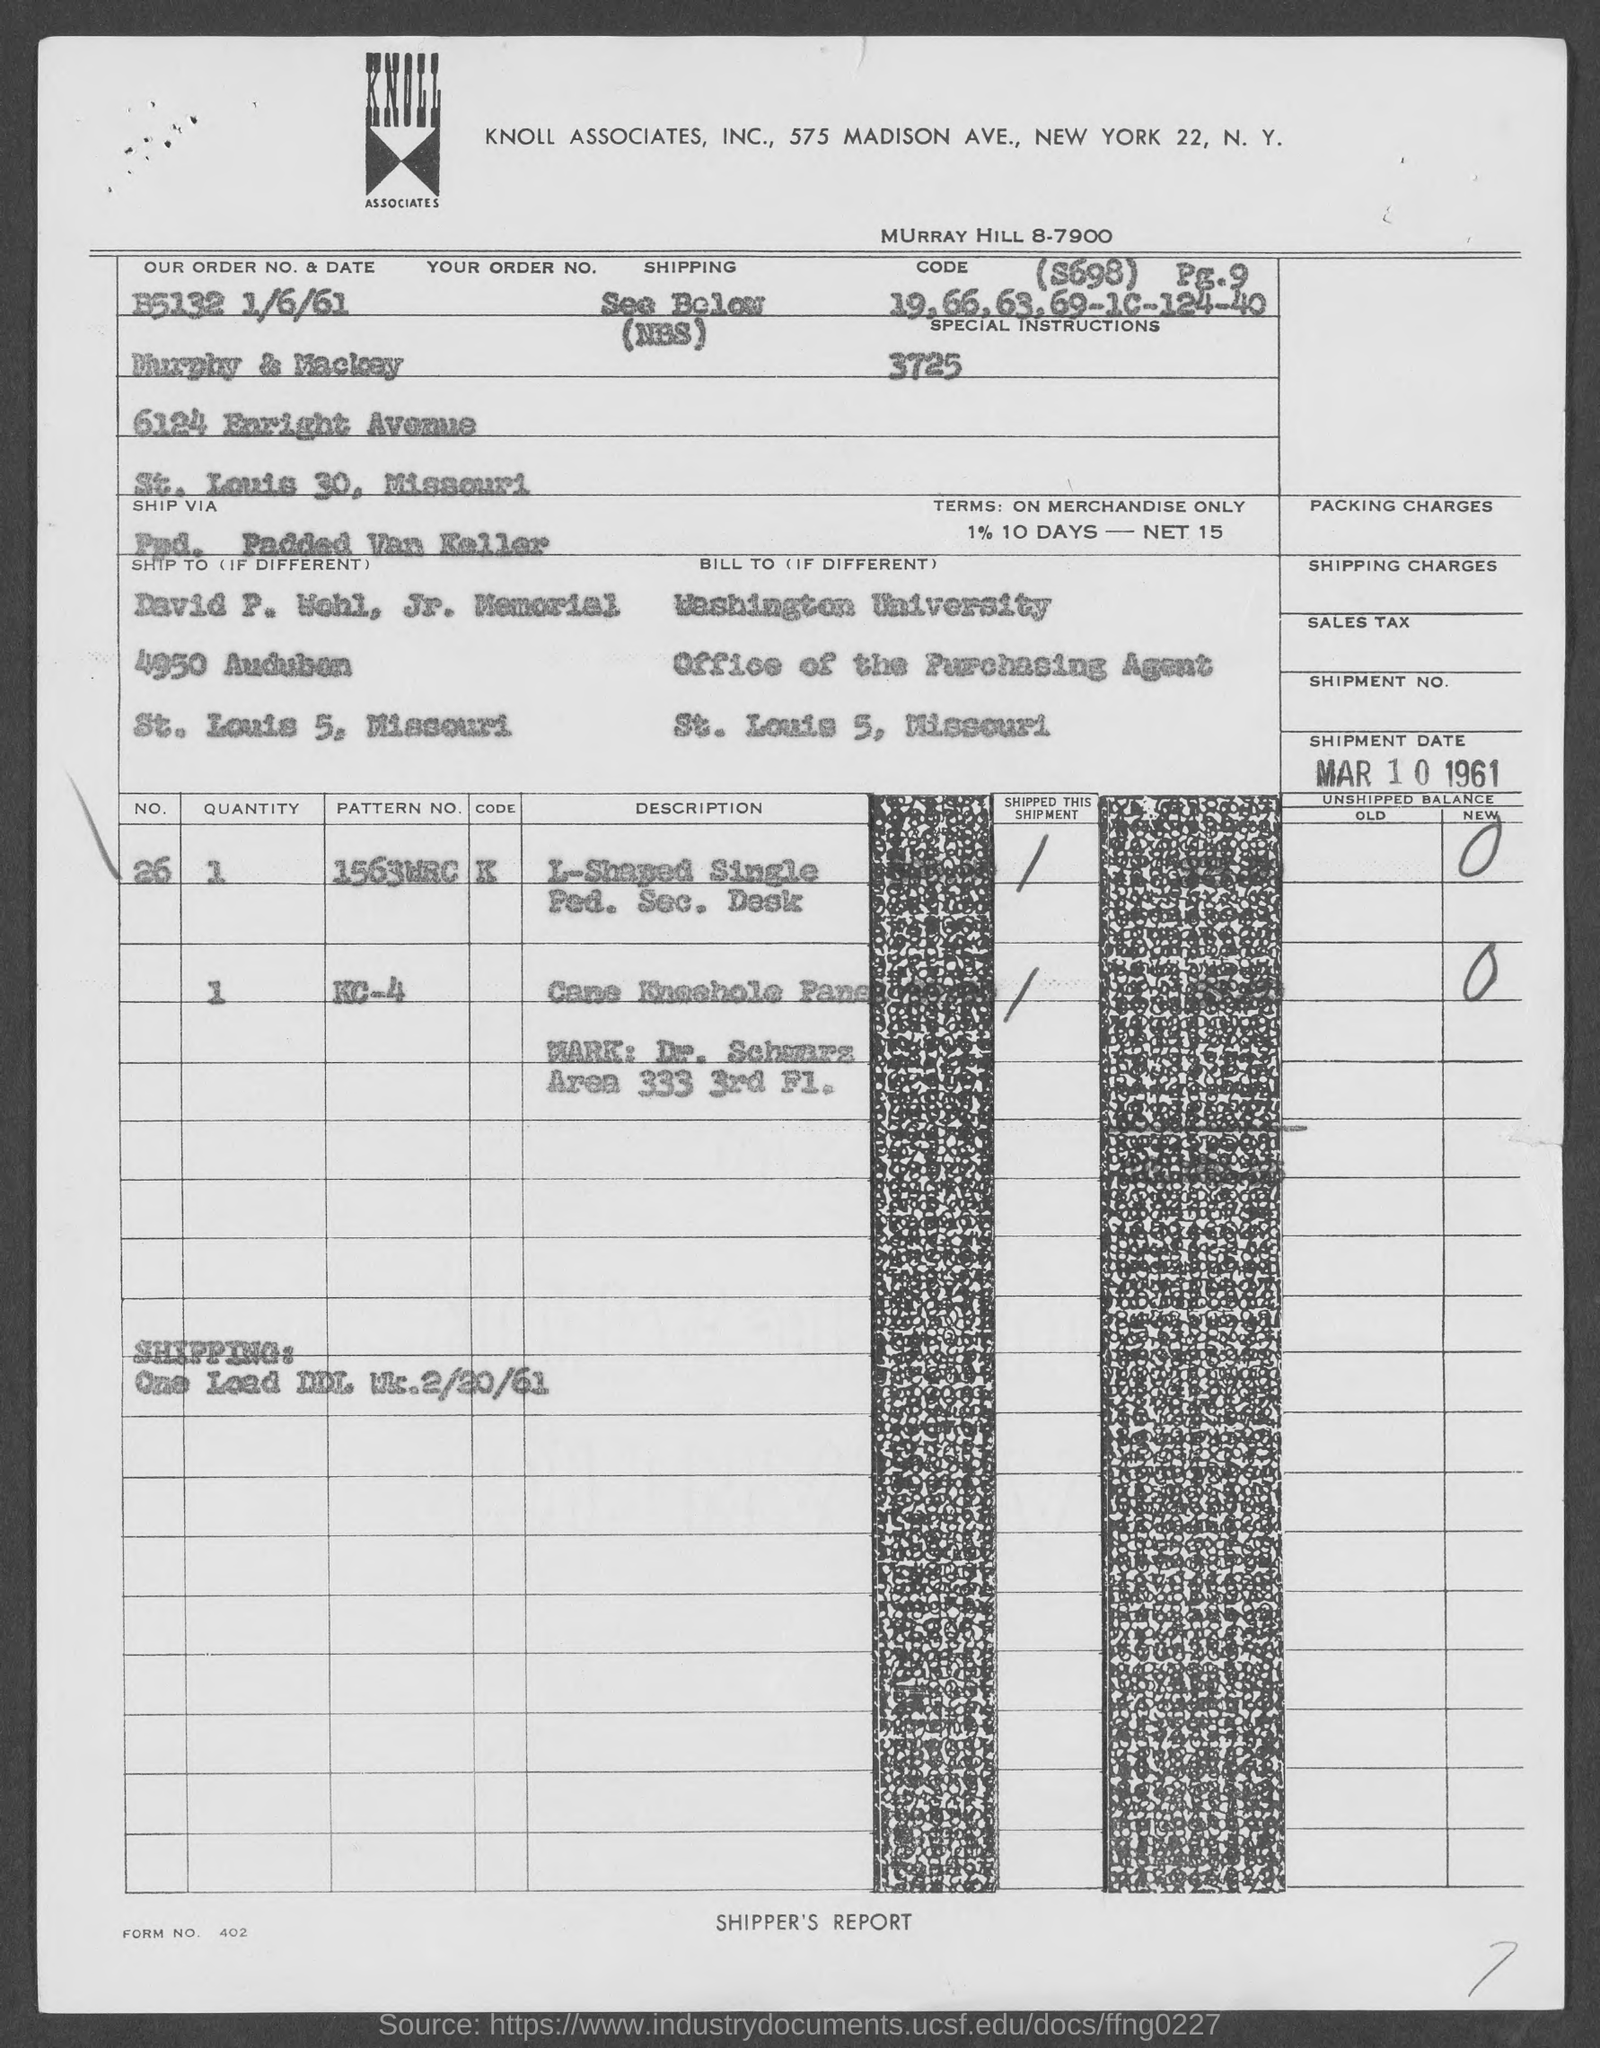Give some essential details in this illustration. The order number is B5132, consisting of 6 digits. David P. Wohl, Jr. Memorial is located in the state of Missouri. What is the form number? As of today's date, January 6th, 1961, is the current date. Washington University is located in St. Louis County. 